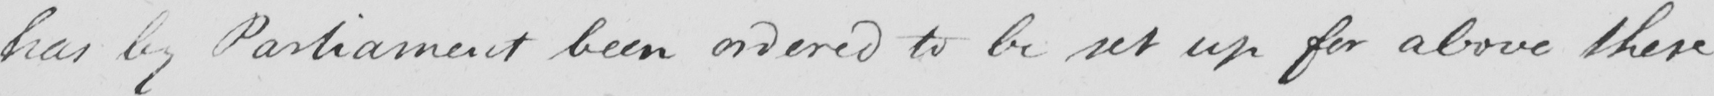What text is written in this handwritten line? has by Parliament been ordered to be set up for above these 